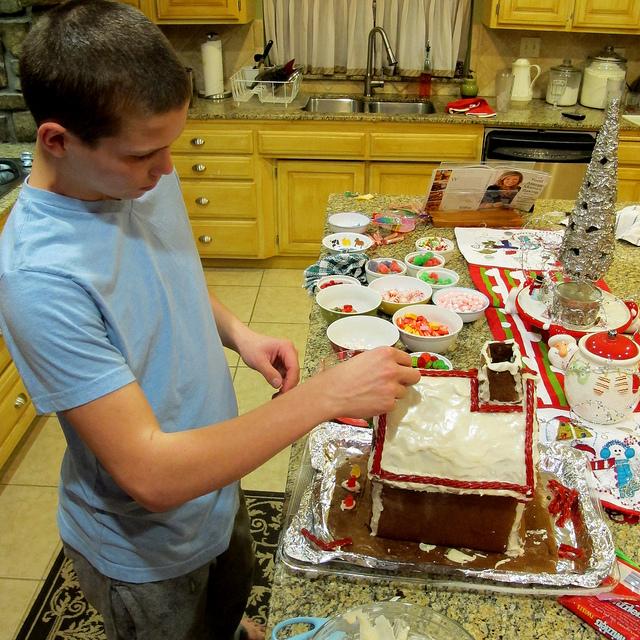What colors are on the shirt to the left?
Keep it brief. Blue. Who is preparing the food?
Give a very brief answer. Boy. What is in the little bowls?
Give a very brief answer. Candy. What color is the shirt?
Be succinct. Blue. What is the boy doing?
Short answer required. Making gingerbread house. Where are the cakes?
Give a very brief answer. Counter. What season would this picture have been taken in?
Answer briefly. Christmas. 